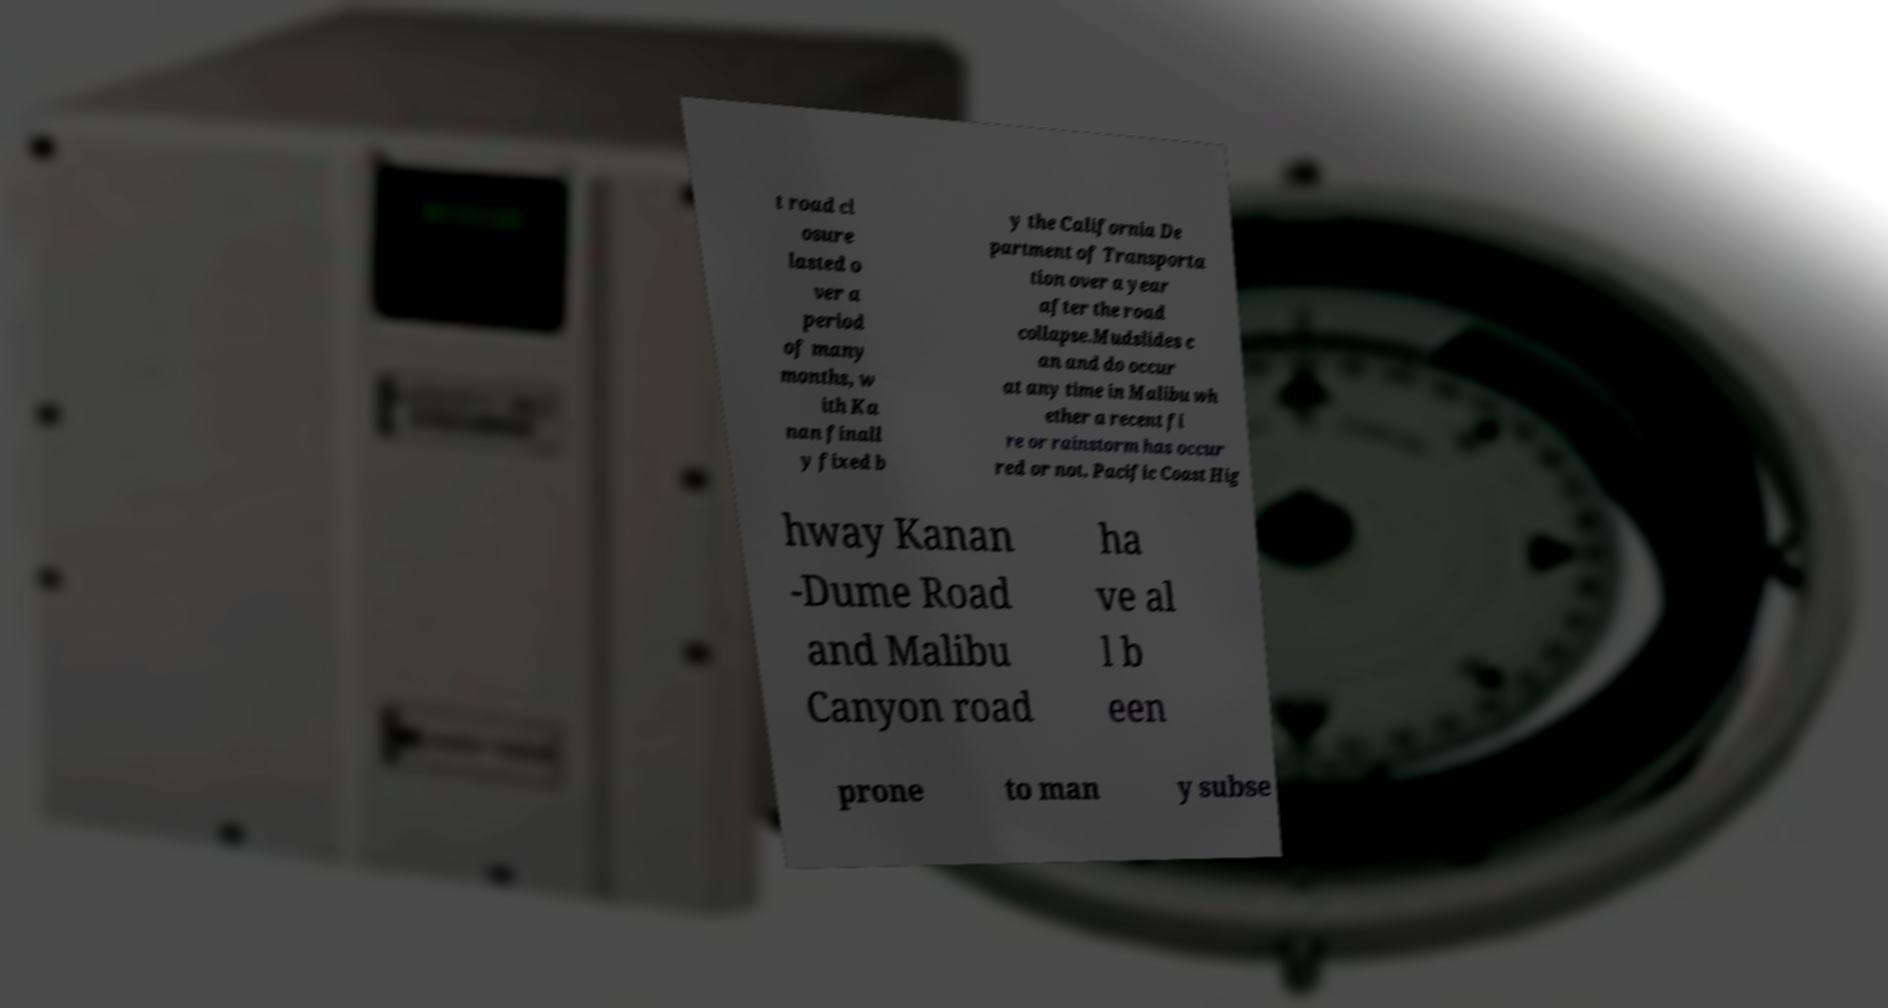Could you assist in decoding the text presented in this image and type it out clearly? t road cl osure lasted o ver a period of many months, w ith Ka nan finall y fixed b y the California De partment of Transporta tion over a year after the road collapse.Mudslides c an and do occur at any time in Malibu wh ether a recent fi re or rainstorm has occur red or not. Pacific Coast Hig hway Kanan -Dume Road and Malibu Canyon road ha ve al l b een prone to man y subse 